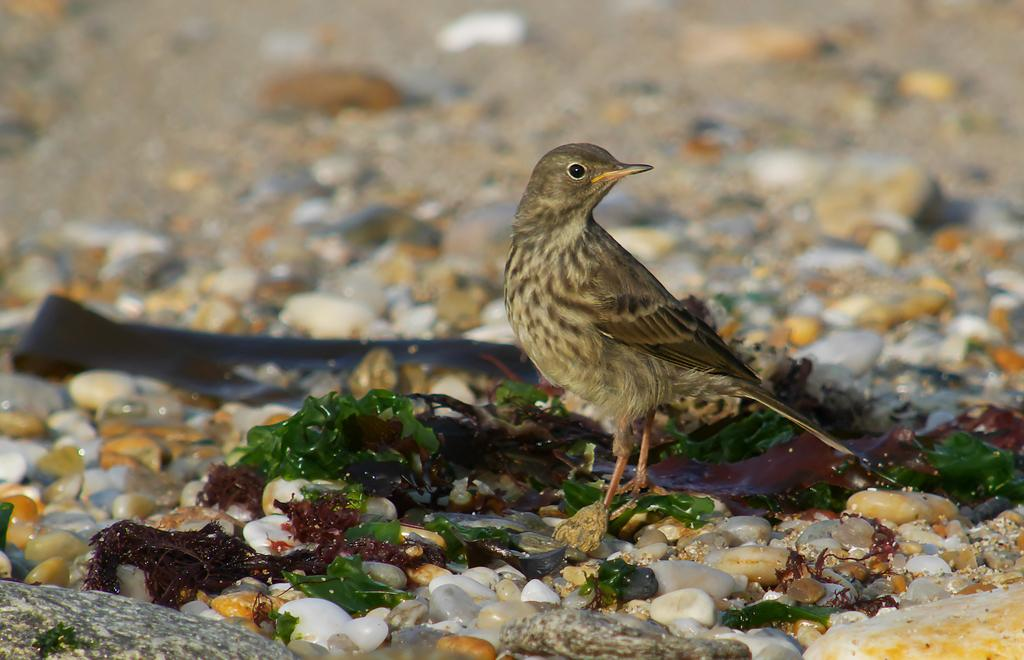What type of animal can be seen in the image? There is a bird in the image. What other objects are present in the image? There are stones in the image. What type of agreement did the bird and the tramp reach in the image? There is no tramp present in the image, and therefore no agreement can be observed. 